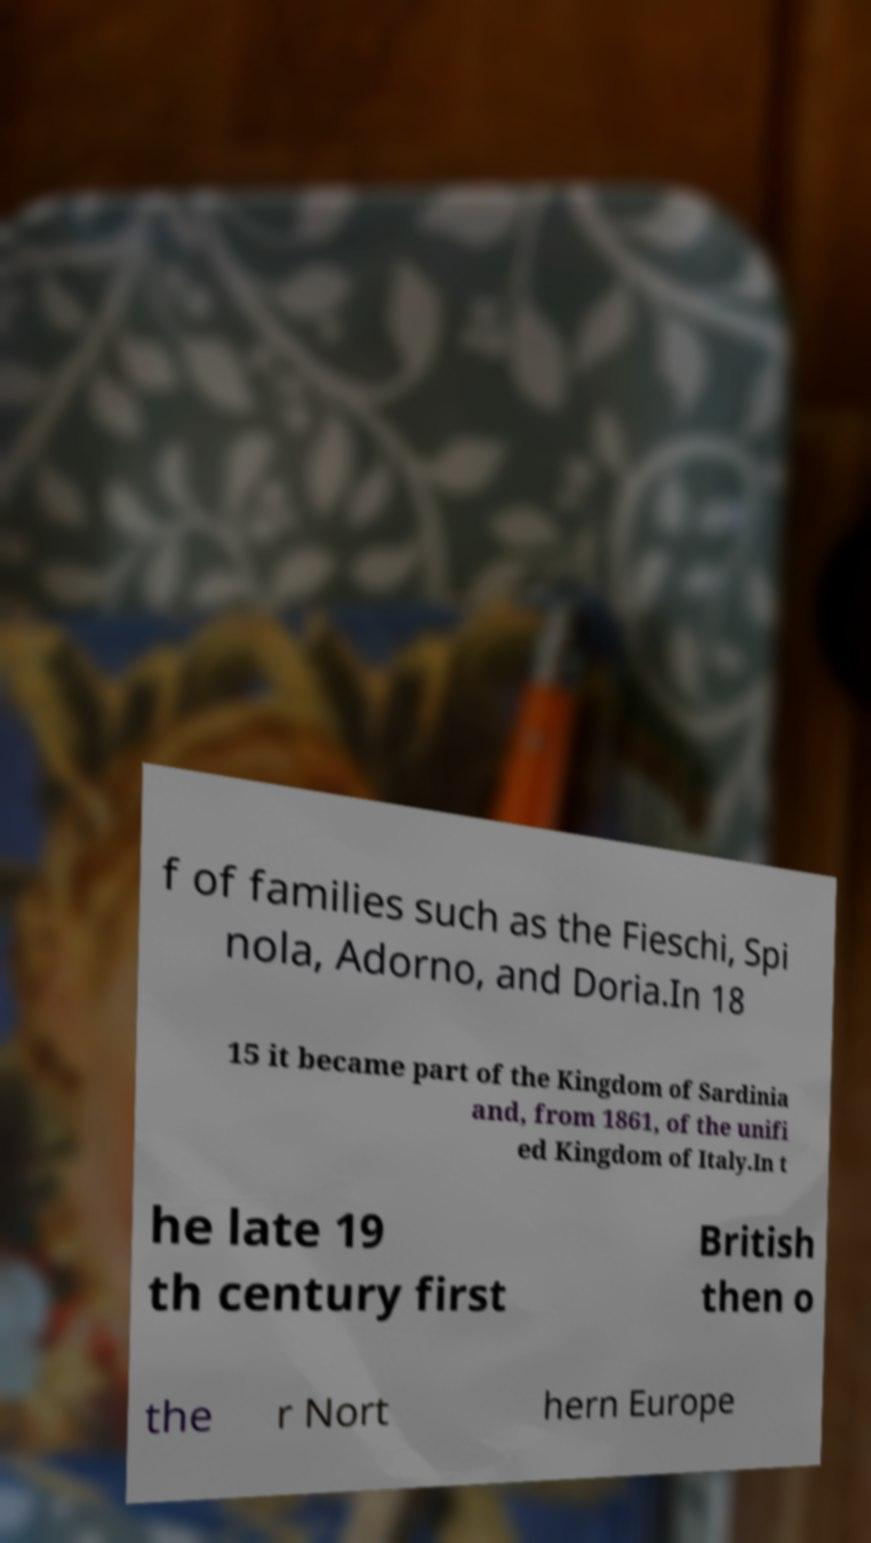Could you extract and type out the text from this image? f of families such as the Fieschi, Spi nola, Adorno, and Doria.In 18 15 it became part of the Kingdom of Sardinia and, from 1861, of the unifi ed Kingdom of Italy.In t he late 19 th century first British then o the r Nort hern Europe 